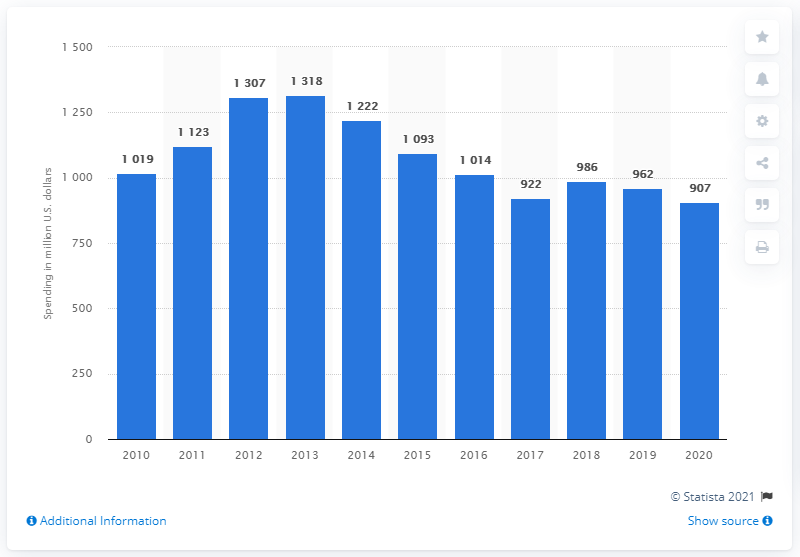Identify some key points in this picture. Royal Dutch Shell spent 907 million on research and development in its 2020 fiscal year. 